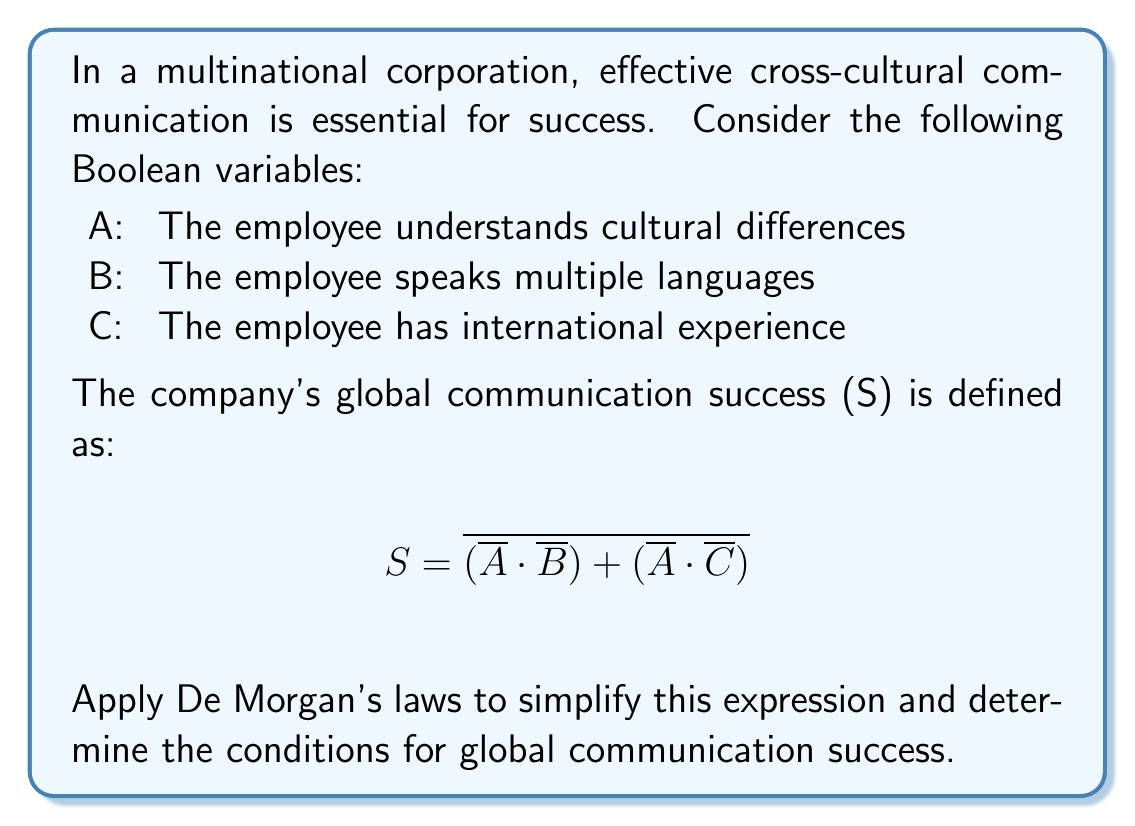Could you help me with this problem? Let's apply De Morgan's laws step-by-step to simplify the expression:

1. Start with the given expression:
   $S = \overline{(\overline{A} \cdot \overline{B}) + (\overline{A} \cdot \overline{C})}$

2. Apply the first De Morgan's law to the outer negation:
   $S = \overline{(\overline{A} \cdot \overline{B})} \cdot \overline{(\overline{A} \cdot \overline{C})}$

3. Apply the second De Morgan's law to each term:
   $S = (A + B) \cdot (A + C)$

4. Distribute the terms:
   $S = A \cdot A + A \cdot C + B \cdot A + B \cdot C$

5. Simplify using the idempotent law (A · A = A):
   $S = A + A \cdot C + B \cdot A + B \cdot C$

6. Factor out A:
   $S = A \cdot (1 + C) + B \cdot (A + C)$

7. Simplify using the identity law (1 + C = 1):
   $S = A + B \cdot (A + C)$

The simplified expression shows that global communication success is achieved when:
- The employee understands cultural differences (A), OR
- The employee speaks multiple languages (B) AND either understands cultural differences (A) or has international experience (C).
Answer: $S = A + B \cdot (A + C)$ 